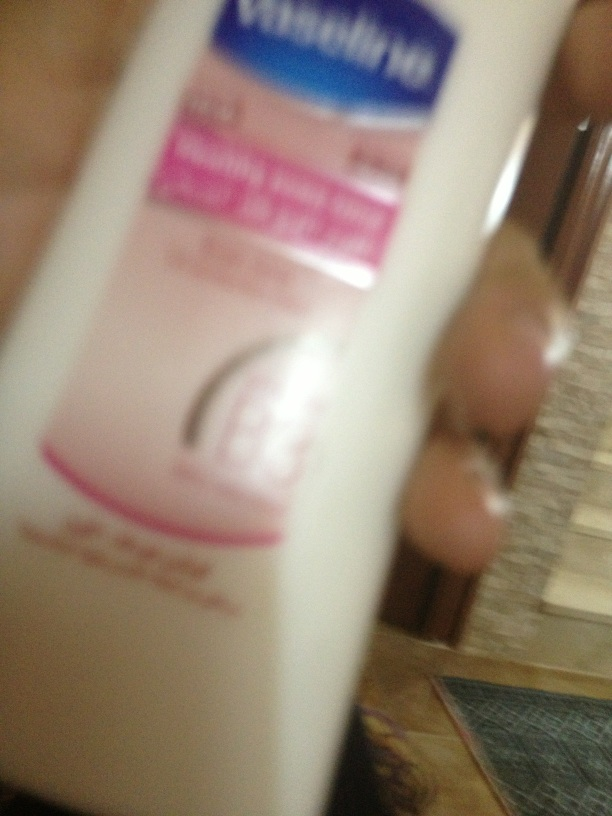What's this? This appears to be a bottle of Vaseline lotion, likely a moisturizing lotion for skin care. 